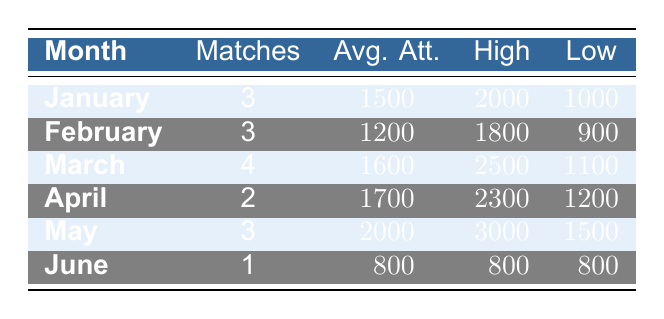What is the highest attendance in March? The table indicates that the highest attendance for March is 2500.
Answer: 2500 Which month had the lowest average attendance? Looking at the average attendance values, February has the lowest average attendance of 1200.
Answer: February In which month was the average attendance above 1800? By examining the table, we see that May has an average attendance of 2000 and April has 1700. Therefore, only May meets the criterion of being above 1800.
Answer: May What is the total number of matches played from January to April? To find the total matches played from January to April, we sum the matches: 3 (January) + 3 (February) + 4 (March) + 2 (April) = 12 matches.
Answer: 12 Is it true that the lowest attendance in June was the lowest attendance for the season? In the table, June's lowest attendance is 800, and looking through previous months, January's lowest was 1000, February's 900, March's 1100, and April's 1200. Therefore, June's lowest attendance of 800 is indeed the lowest of the season.
Answer: Yes What was the average attendance for the months with 3 matches played? The relevant months with 3 matches played are January, February, and May, which have average attendances of 1500, 1200, and 2000 respectively. The average is calculated as (1500 + 1200 + 2000) / 3 = 1566.67, which rounds to 1567.
Answer: 1567 How many matches in total were played from May to June? From the table, May had 3 matches and June had 1 match. Adding them together gives us 3 + 1 = 4 matches.
Answer: 4 Which month had the highest number of matches played in the data? Looking through the matches played, March has the highest number of matches at 4.
Answer: March 